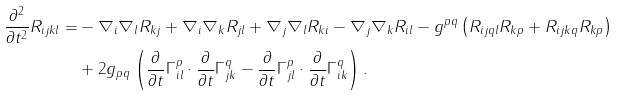<formula> <loc_0><loc_0><loc_500><loc_500>\frac { \partial ^ { 2 } } { \partial t ^ { 2 } } R _ { i j k l } = & - \nabla _ { i } \nabla _ { l } R _ { k j } + \nabla _ { i } \nabla _ { k } R _ { j l } + \nabla _ { j } \nabla _ { l } R _ { k i } - \nabla _ { j } \nabla _ { k } R _ { i l } - g ^ { p q } \left ( R _ { i j q l } R _ { k p } + R _ { i j k q } R _ { k p } \right ) \\ & + 2 g _ { p q } \left ( \frac { \partial } { \partial t } \Gamma ^ { p } _ { i l } \cdot \frac { \partial } { \partial t } \Gamma ^ { q } _ { j k } - \frac { \partial } { \partial t } \Gamma ^ { p } _ { j l } \cdot \frac { \partial } { \partial t } \Gamma ^ { q } _ { i k } \right ) .</formula> 